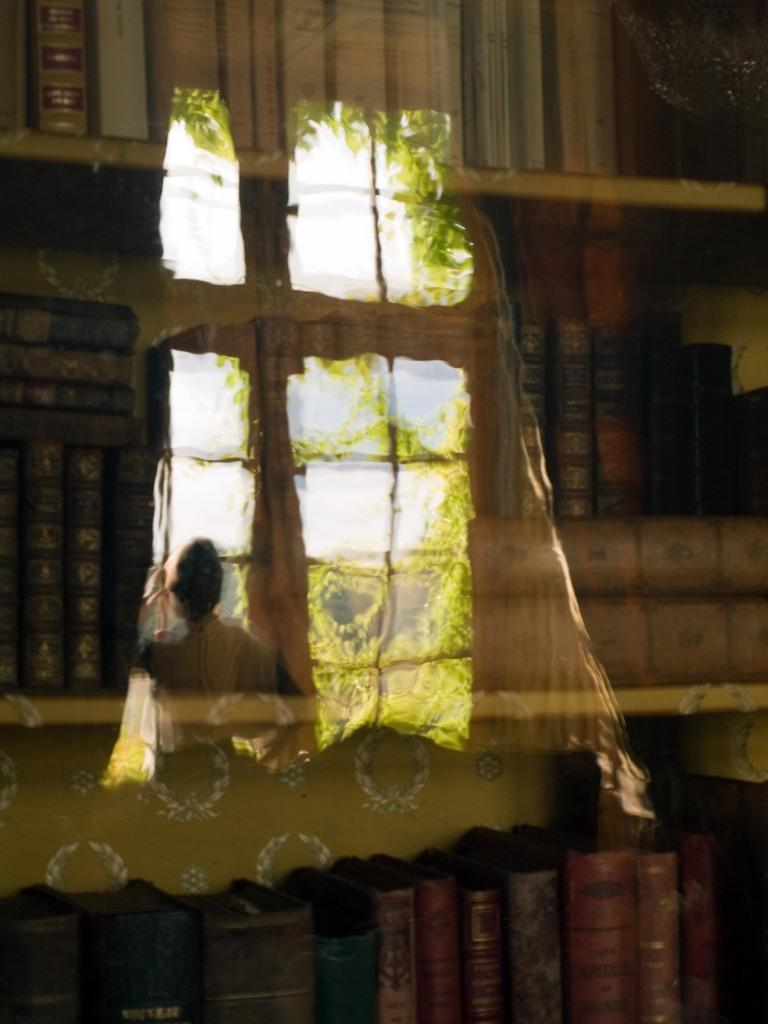What is present in the image that can hold books? There is a bookshelf in the image. What can be seen in the image that is not a solid object? There is a reflection in the image. What type of natural environment is visible in the reflection? Trees are visible in the reflection. Who or what is visible on the left side of the reflection? A person is visible on the left side of the reflection. What brand of toothpaste is the person using in the image? There is no toothpaste present in the image. What color is the sweater worn by the person in the image? The image does not show the person wearing a sweater, so we cannot determine the color. 